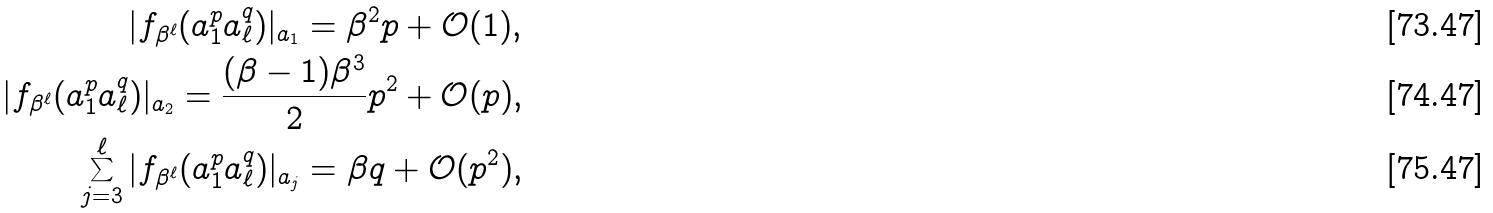Convert formula to latex. <formula><loc_0><loc_0><loc_500><loc_500>| f _ { \beta ^ { \ell } } ( a _ { 1 } ^ { p } a _ { \ell } ^ { q } ) | _ { a _ { 1 } } = \beta ^ { 2 } p + \mathcal { O } ( 1 ) , \\ | f _ { \beta ^ { \ell } } ( a _ { 1 } ^ { p } a _ { \ell } ^ { q } ) | _ { a _ { 2 } } = \frac { ( \beta - 1 ) \beta ^ { 3 } } 2 p ^ { 2 } + \mathcal { O } ( p ) , \\ \sum _ { j = 3 } ^ { \ell } | f _ { \beta ^ { \ell } } ( a _ { 1 } ^ { p } a _ { \ell } ^ { q } ) | _ { a _ { j } } = \beta q + \mathcal { O } ( p ^ { 2 } ) ,</formula> 